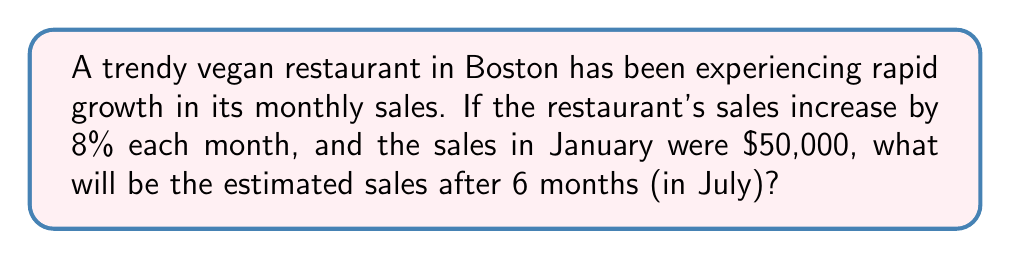Show me your answer to this math problem. Let's approach this step-by-step:

1) We're dealing with exponential growth, where the general formula is:
   $A = P(1 + r)^t$
   Where:
   $A$ = Final amount
   $P$ = Initial principal balance
   $r$ = Growth rate (as a decimal)
   $t$ = Number of time periods

2) In this case:
   $P = 50,000$ (initial sales in January)
   $r = 0.08$ (8% growth rate expressed as a decimal)
   $t = 6$ (6 months from January to July)

3) Let's plug these values into our formula:
   $A = 50,000(1 + 0.08)^6$

4) Simplify inside the parentheses:
   $A = 50,000(1.08)^6$

5) Calculate the exponent:
   $(1.08)^6 \approx 1.5869$ (rounded to 4 decimal places)

6) Multiply:
   $A = 50,000 * 1.5869 = 79,345$

Therefore, the estimated sales in July will be approximately $79,345.
Answer: $79,345 